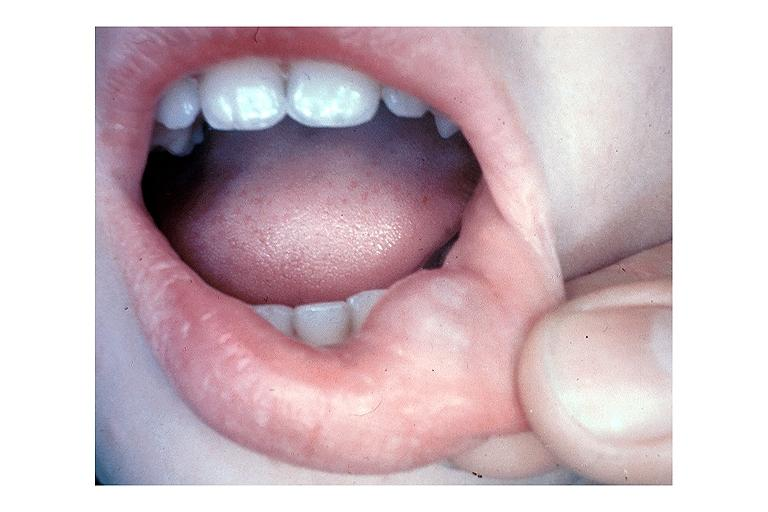s metastatic carcinoma breast present?
Answer the question using a single word or phrase. No 